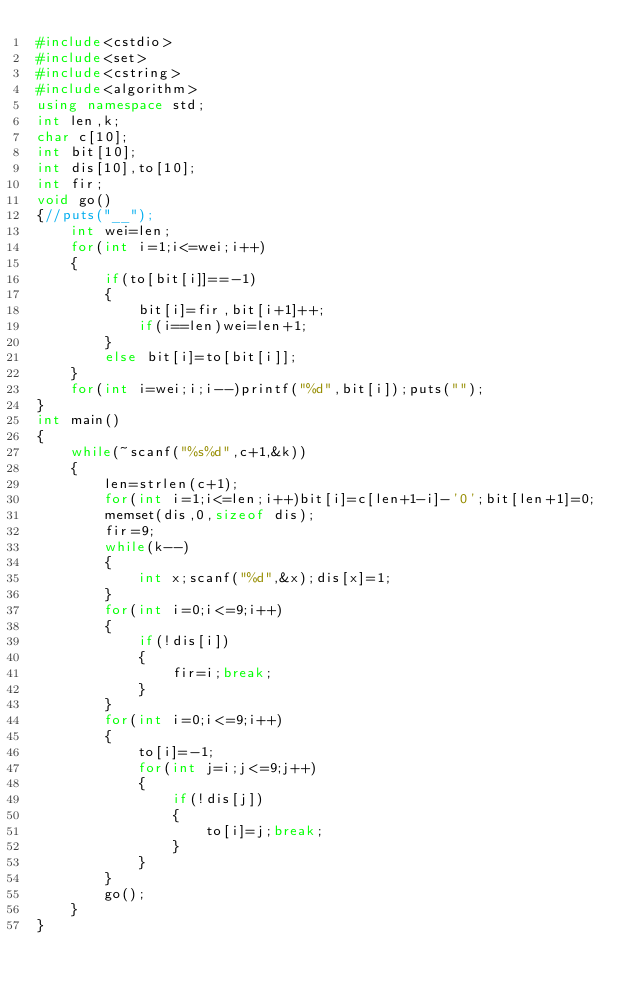Convert code to text. <code><loc_0><loc_0><loc_500><loc_500><_C++_>#include<cstdio>
#include<set>
#include<cstring>
#include<algorithm>
using namespace std;
int len,k;
char c[10];
int bit[10];
int dis[10],to[10];
int fir;
void go()
{//puts("__");
    int wei=len;
    for(int i=1;i<=wei;i++)
    {
        if(to[bit[i]]==-1)
        {
            bit[i]=fir,bit[i+1]++;
            if(i==len)wei=len+1;
        }
        else bit[i]=to[bit[i]];
    }
    for(int i=wei;i;i--)printf("%d",bit[i]);puts("");
}
int main()
{
    while(~scanf("%s%d",c+1,&k))
    {
        len=strlen(c+1);
        for(int i=1;i<=len;i++)bit[i]=c[len+1-i]-'0';bit[len+1]=0;
        memset(dis,0,sizeof dis);
        fir=9;
        while(k--)
        {
            int x;scanf("%d",&x);dis[x]=1;
        }
        for(int i=0;i<=9;i++)
        {
            if(!dis[i])
            {
                fir=i;break;
            }
        }
        for(int i=0;i<=9;i++)
        {
            to[i]=-1;
            for(int j=i;j<=9;j++)
            {
                if(!dis[j])
                {
                    to[i]=j;break;
                }
            }
        }
        go();
    }
}
</code> 